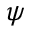<formula> <loc_0><loc_0><loc_500><loc_500>\psi</formula> 